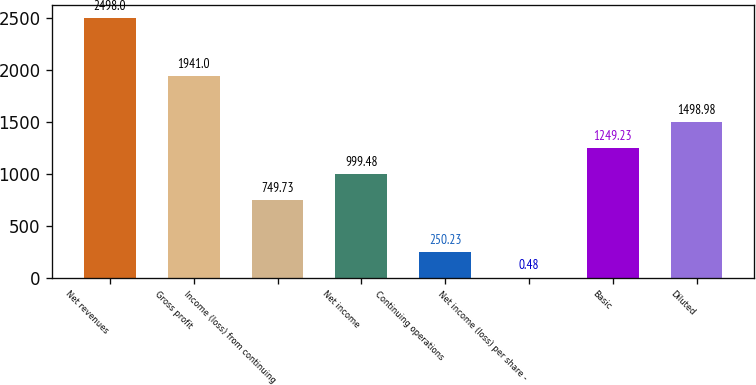Convert chart. <chart><loc_0><loc_0><loc_500><loc_500><bar_chart><fcel>Net revenues<fcel>Gross profit<fcel>Income (loss) from continuing<fcel>Net income<fcel>Continuing operations<fcel>Net income (loss) per share -<fcel>Basic<fcel>Diluted<nl><fcel>2498<fcel>1941<fcel>749.73<fcel>999.48<fcel>250.23<fcel>0.48<fcel>1249.23<fcel>1498.98<nl></chart> 